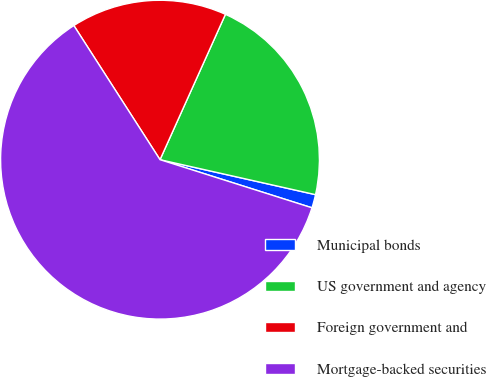Convert chart to OTSL. <chart><loc_0><loc_0><loc_500><loc_500><pie_chart><fcel>Municipal bonds<fcel>US government and agency<fcel>Foreign government and<fcel>Mortgage-backed securities<nl><fcel>1.36%<fcel>21.79%<fcel>15.82%<fcel>61.03%<nl></chart> 